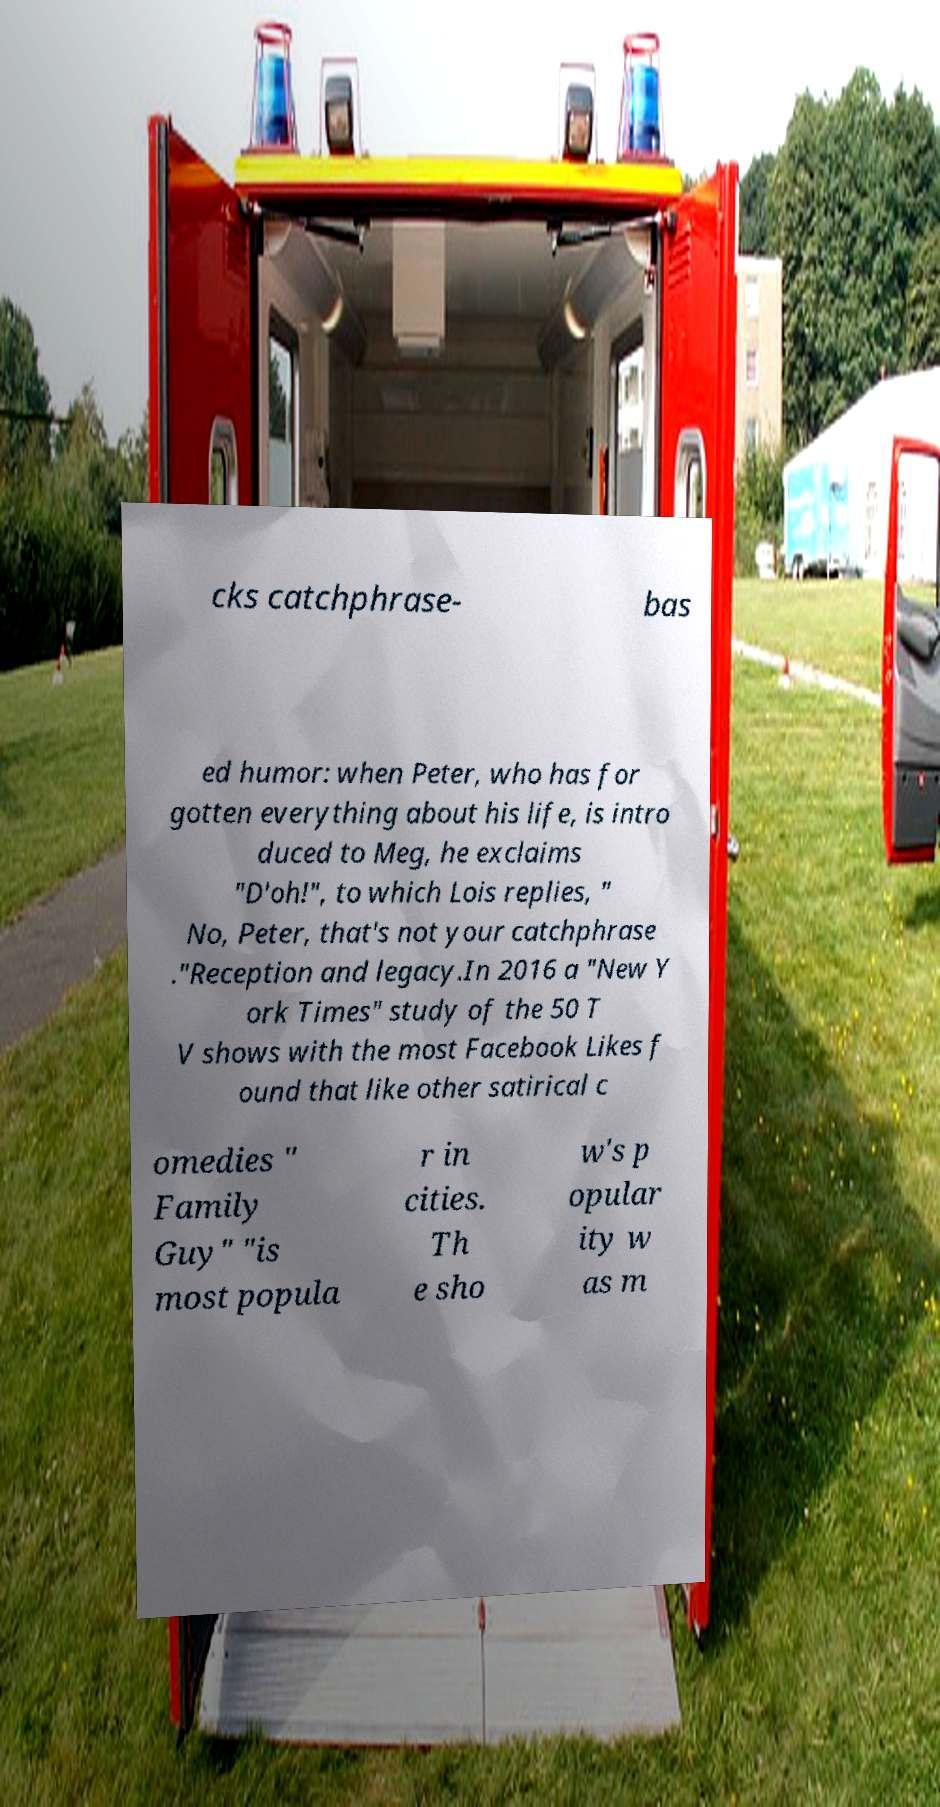Can you read and provide the text displayed in the image?This photo seems to have some interesting text. Can you extract and type it out for me? cks catchphrase- bas ed humor: when Peter, who has for gotten everything about his life, is intro duced to Meg, he exclaims "D'oh!", to which Lois replies, " No, Peter, that's not your catchphrase ."Reception and legacy.In 2016 a "New Y ork Times" study of the 50 T V shows with the most Facebook Likes f ound that like other satirical c omedies " Family Guy" "is most popula r in cities. Th e sho w's p opular ity w as m 